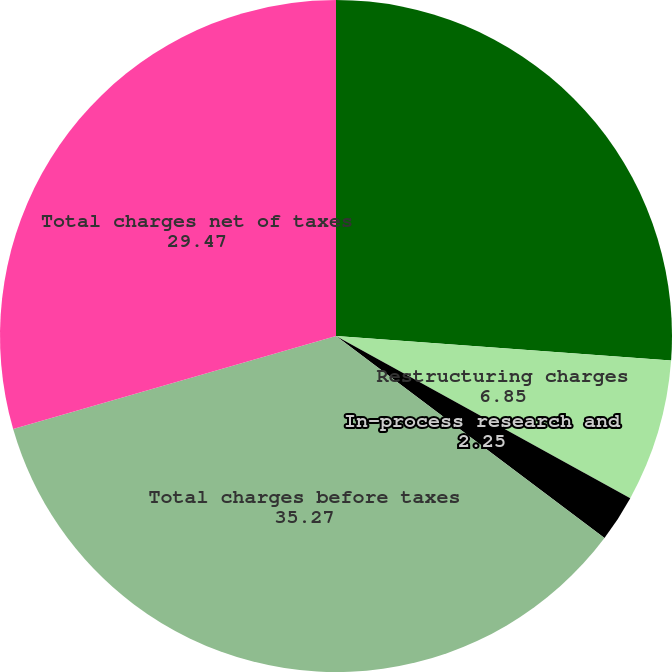Convert chart to OTSL. <chart><loc_0><loc_0><loc_500><loc_500><pie_chart><fcel>Amortization of purchased<fcel>Restructuring charges<fcel>In-process research and<fcel>Total charges before taxes<fcel>Total charges net of taxes<nl><fcel>26.17%<fcel>6.85%<fcel>2.25%<fcel>35.27%<fcel>29.47%<nl></chart> 